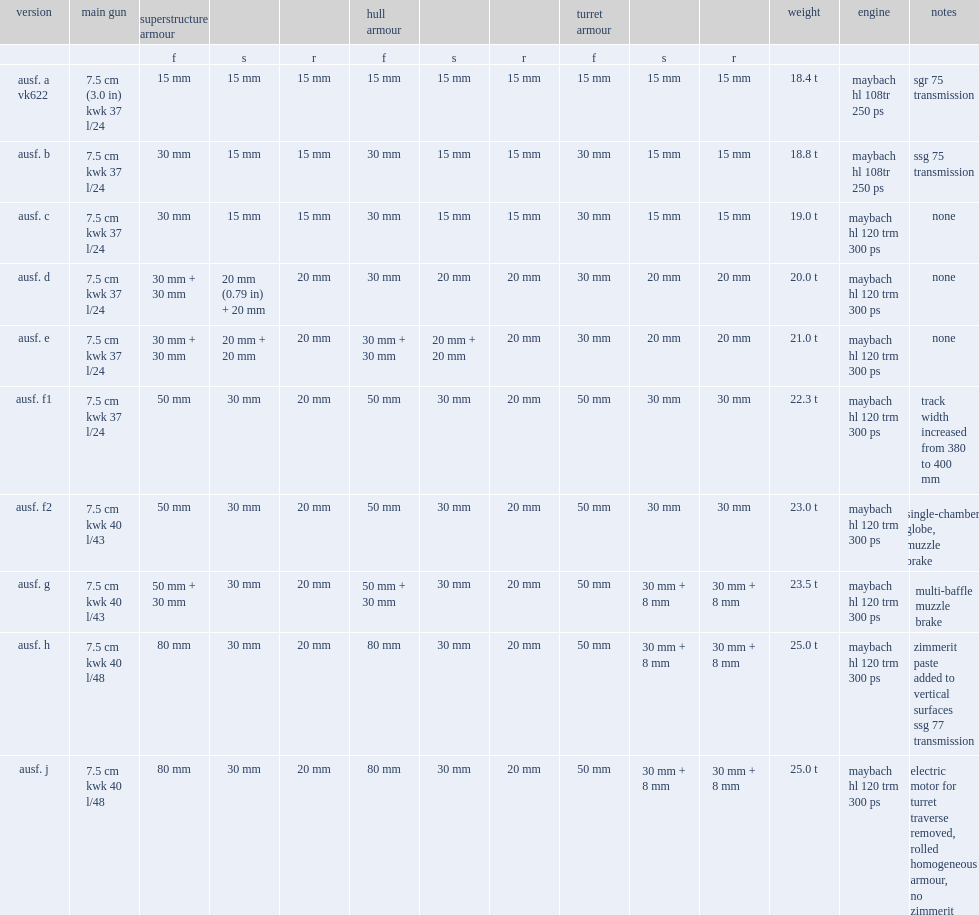What was ausf's weight? 18.4 t. 